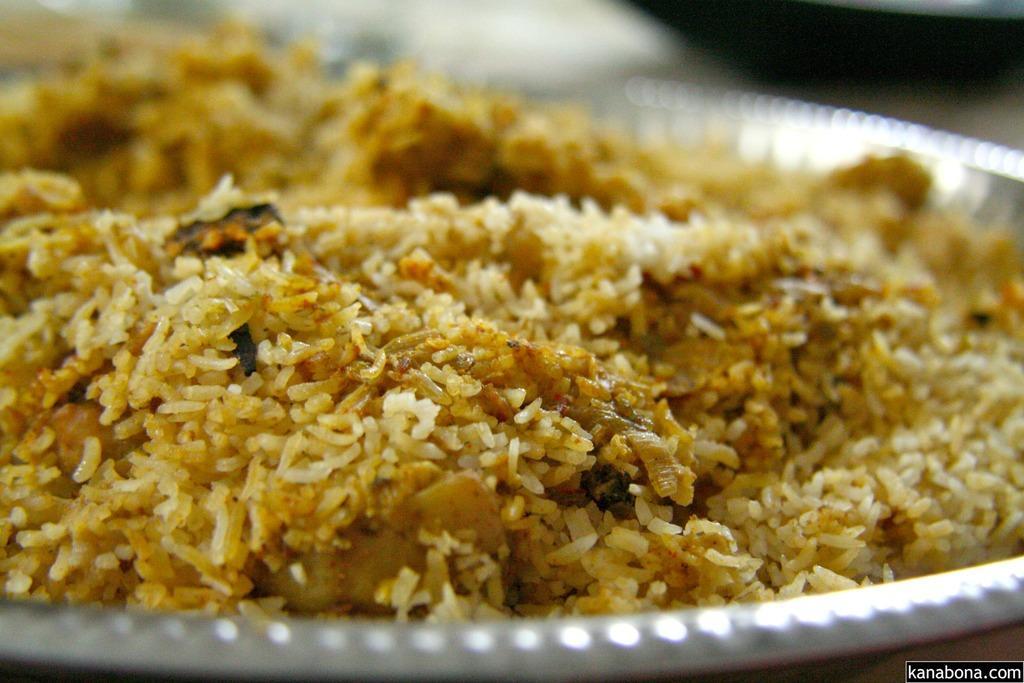How would you summarize this image in a sentence or two? In this image I can see the food in the plate. The food is in brown color and the plate is in white color. 